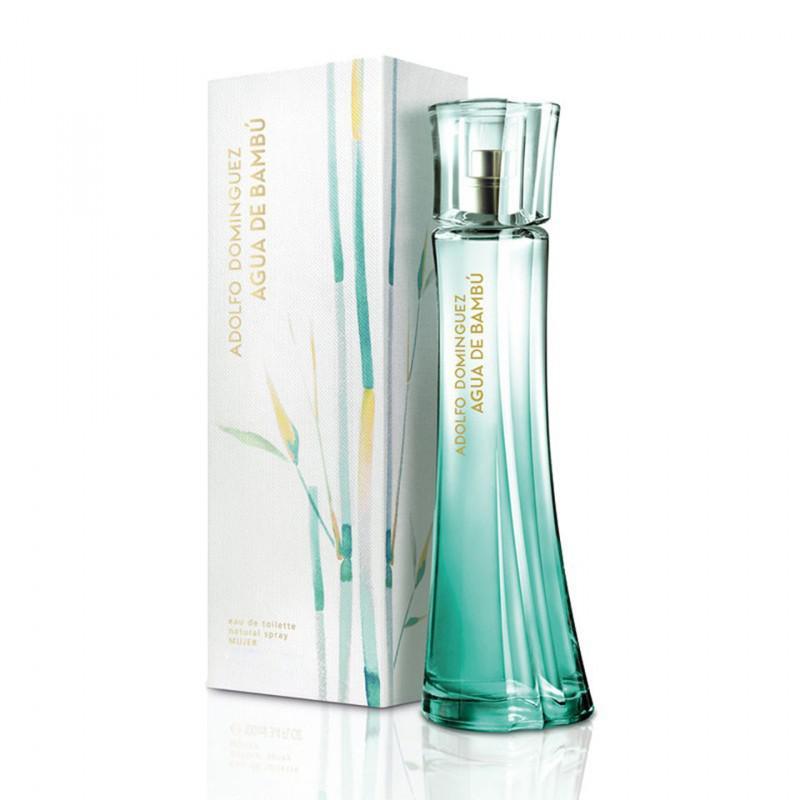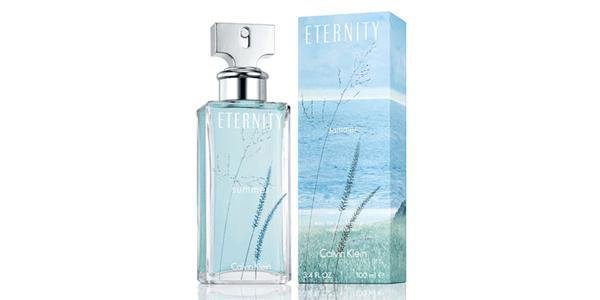The first image is the image on the left, the second image is the image on the right. Assess this claim about the two images: "There are at most two bottles of perfume.". Correct or not? Answer yes or no. Yes. 